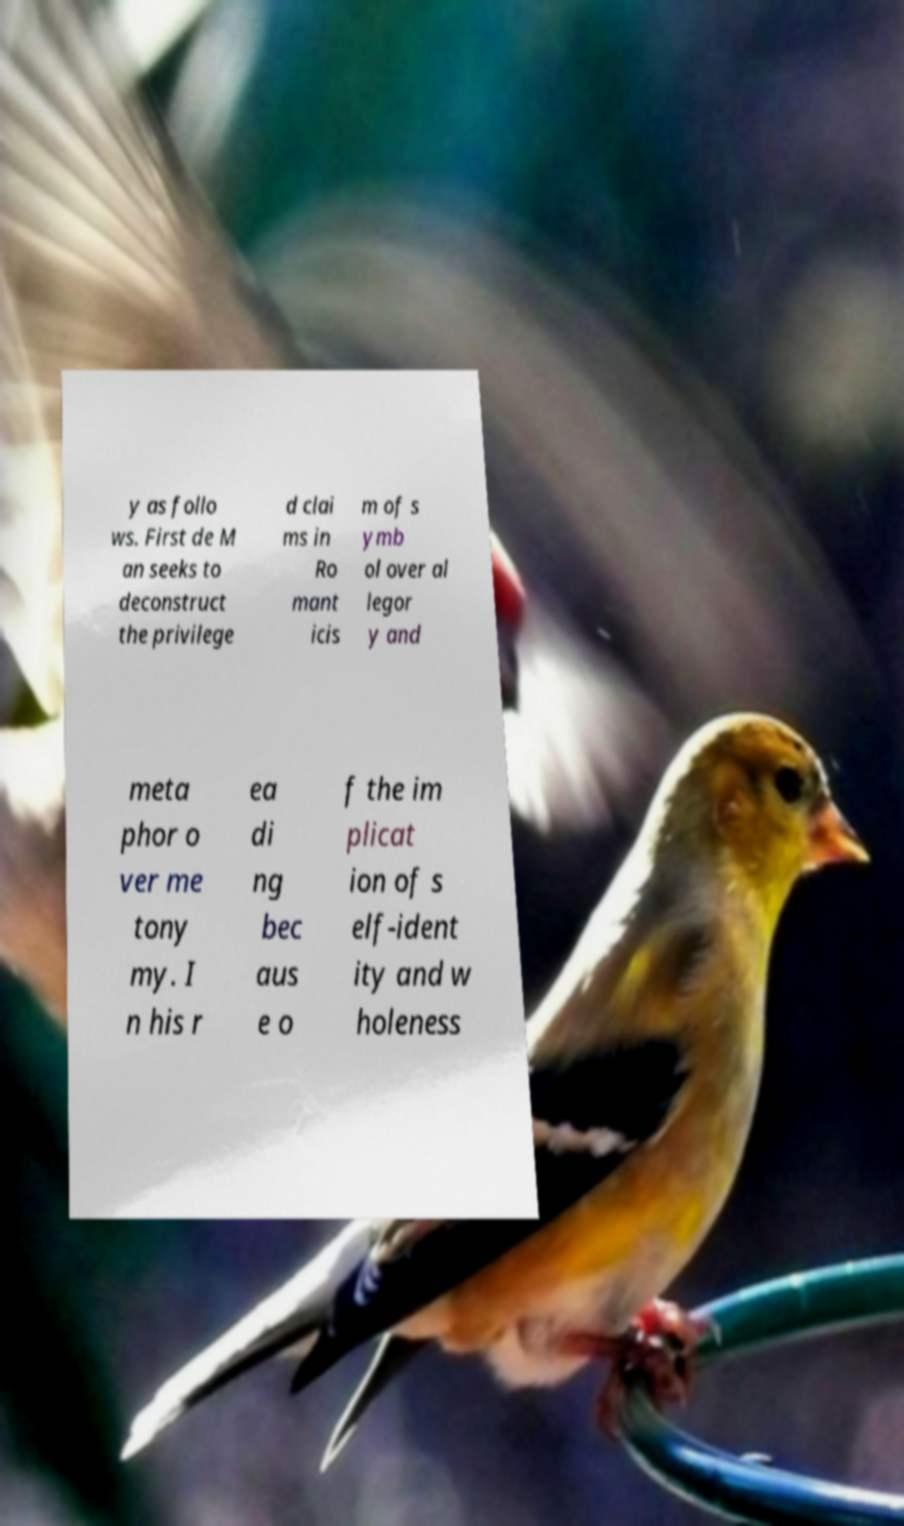I need the written content from this picture converted into text. Can you do that? y as follo ws. First de M an seeks to deconstruct the privilege d clai ms in Ro mant icis m of s ymb ol over al legor y and meta phor o ver me tony my. I n his r ea di ng bec aus e o f the im plicat ion of s elf-ident ity and w holeness 